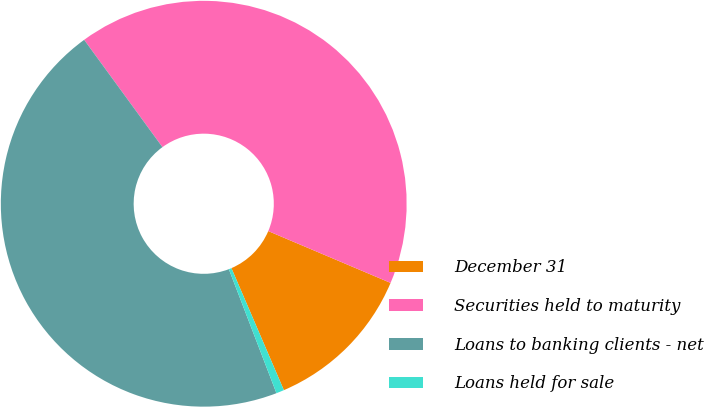Convert chart to OTSL. <chart><loc_0><loc_0><loc_500><loc_500><pie_chart><fcel>December 31<fcel>Securities held to maturity<fcel>Loans to banking clients - net<fcel>Loans held for sale<nl><fcel>12.16%<fcel>41.41%<fcel>45.8%<fcel>0.63%<nl></chart> 